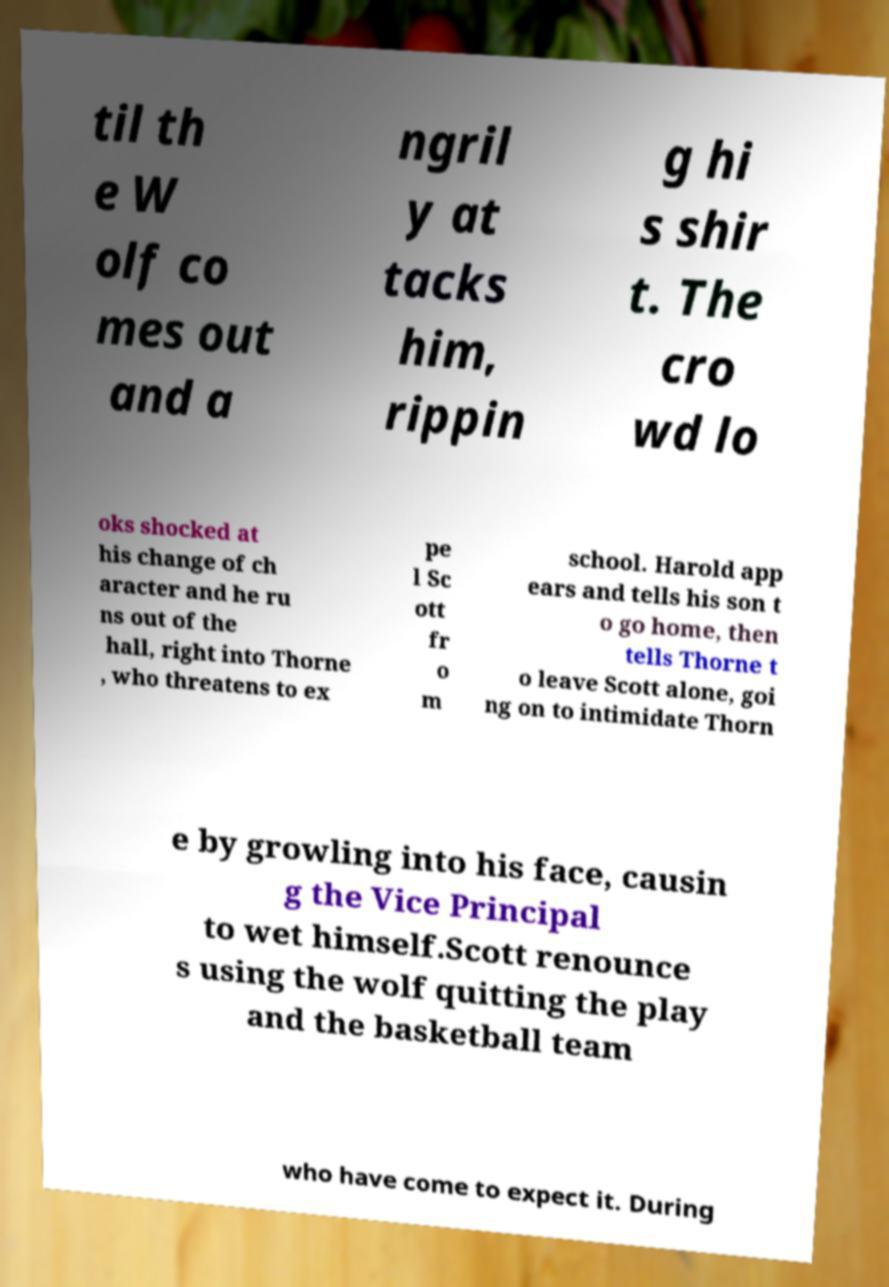Can you accurately transcribe the text from the provided image for me? til th e W olf co mes out and a ngril y at tacks him, rippin g hi s shir t. The cro wd lo oks shocked at his change of ch aracter and he ru ns out of the hall, right into Thorne , who threatens to ex pe l Sc ott fr o m school. Harold app ears and tells his son t o go home, then tells Thorne t o leave Scott alone, goi ng on to intimidate Thorn e by growling into his face, causin g the Vice Principal to wet himself.Scott renounce s using the wolf quitting the play and the basketball team who have come to expect it. During 